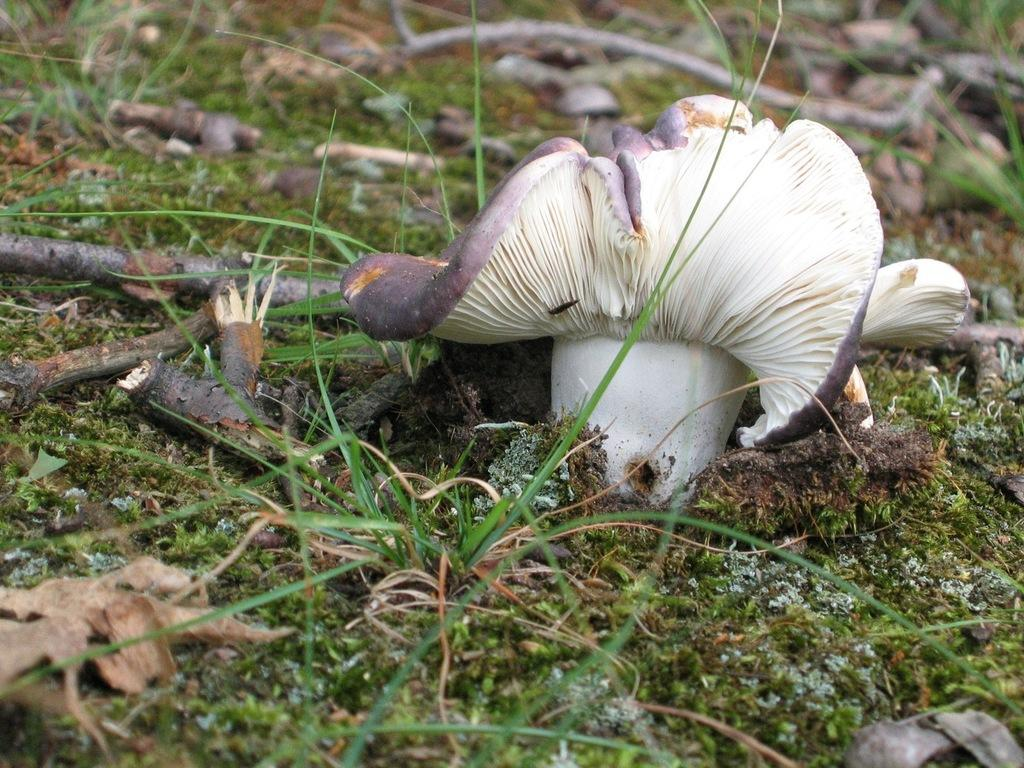What type of surface is present in the image? The image contains a grass surface. What objects can be seen on the grass surface? There are sticks visible on the grass surface. What type of fungus is present in the image? There is a mushroom in the image. What are the color characteristics of the mushroom? The mushroom has a cream color, and some parts of it are white in color. Who is the owner of the toes visible in the image? There are no toes visible in the image. 